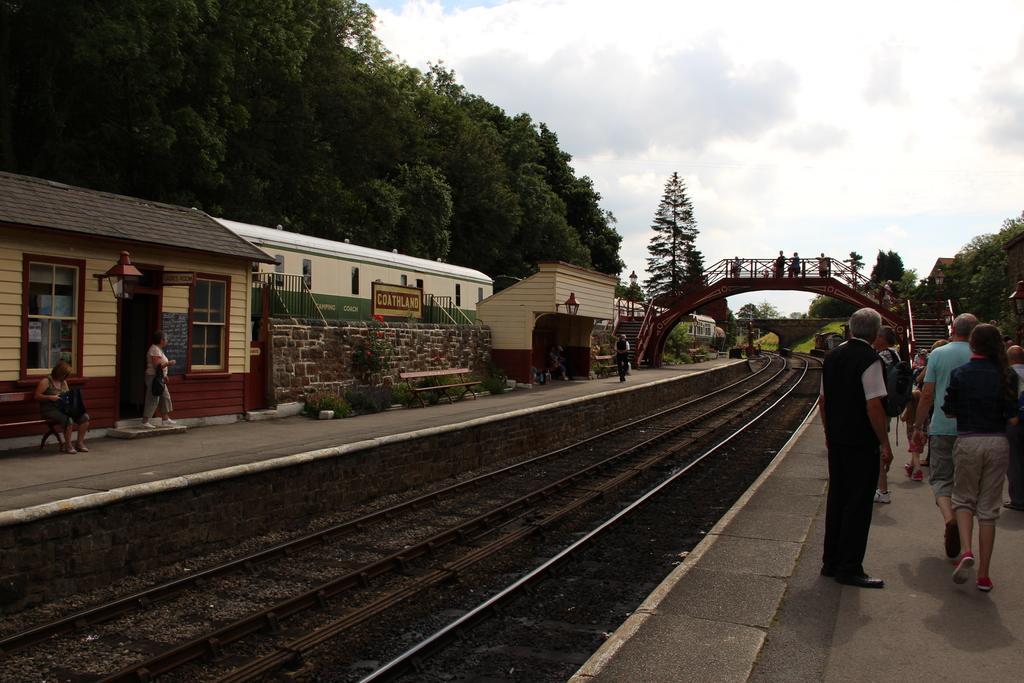In one or two sentences, can you explain what this image depicts? In this image I can see the track. To the side of the track there is a platform. On the platform I can see the group of people standing and wearing the different color dresses. I can see few people with bags. To the left there are buildings. In the background I can see the bridge and railing. I can see few people on the bridge. I can also see many trees, clouds and the sky in the back. 